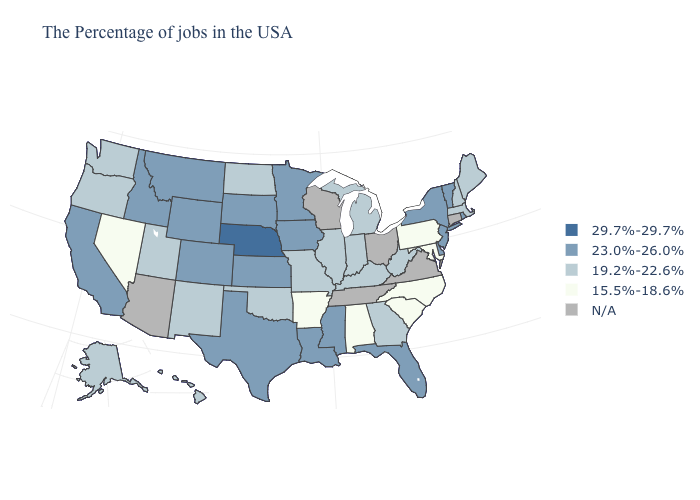Name the states that have a value in the range N/A?
Short answer required. Connecticut, Virginia, Ohio, Tennessee, Wisconsin, Arizona. What is the value of New York?
Short answer required. 23.0%-26.0%. Among the states that border Minnesota , which have the lowest value?
Quick response, please. North Dakota. Does Iowa have the highest value in the MidWest?
Keep it brief. No. What is the lowest value in the USA?
Concise answer only. 15.5%-18.6%. What is the value of Illinois?
Concise answer only. 19.2%-22.6%. What is the lowest value in states that border Maine?
Short answer required. 19.2%-22.6%. Does the first symbol in the legend represent the smallest category?
Keep it brief. No. What is the value of South Dakota?
Short answer required. 23.0%-26.0%. What is the value of Indiana?
Write a very short answer. 19.2%-22.6%. What is the lowest value in the USA?
Short answer required. 15.5%-18.6%. What is the value of New Hampshire?
Write a very short answer. 19.2%-22.6%. What is the lowest value in states that border New Jersey?
Short answer required. 15.5%-18.6%. What is the highest value in the South ?
Be succinct. 23.0%-26.0%. 